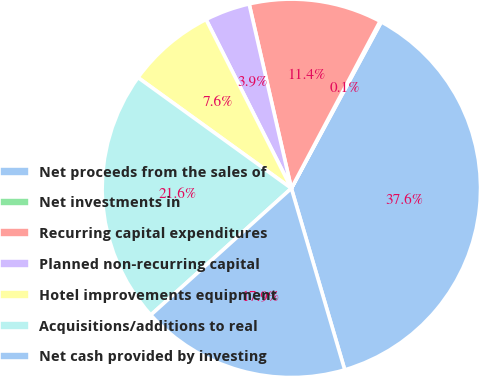Convert chart to OTSL. <chart><loc_0><loc_0><loc_500><loc_500><pie_chart><fcel>Net proceeds from the sales of<fcel>Net investments in<fcel>Recurring capital expenditures<fcel>Planned non-recurring capital<fcel>Hotel improvements equipment<fcel>Acquisitions/additions to real<fcel>Net cash provided by investing<nl><fcel>37.56%<fcel>0.12%<fcel>11.35%<fcel>3.86%<fcel>7.6%<fcel>21.63%<fcel>17.88%<nl></chart> 